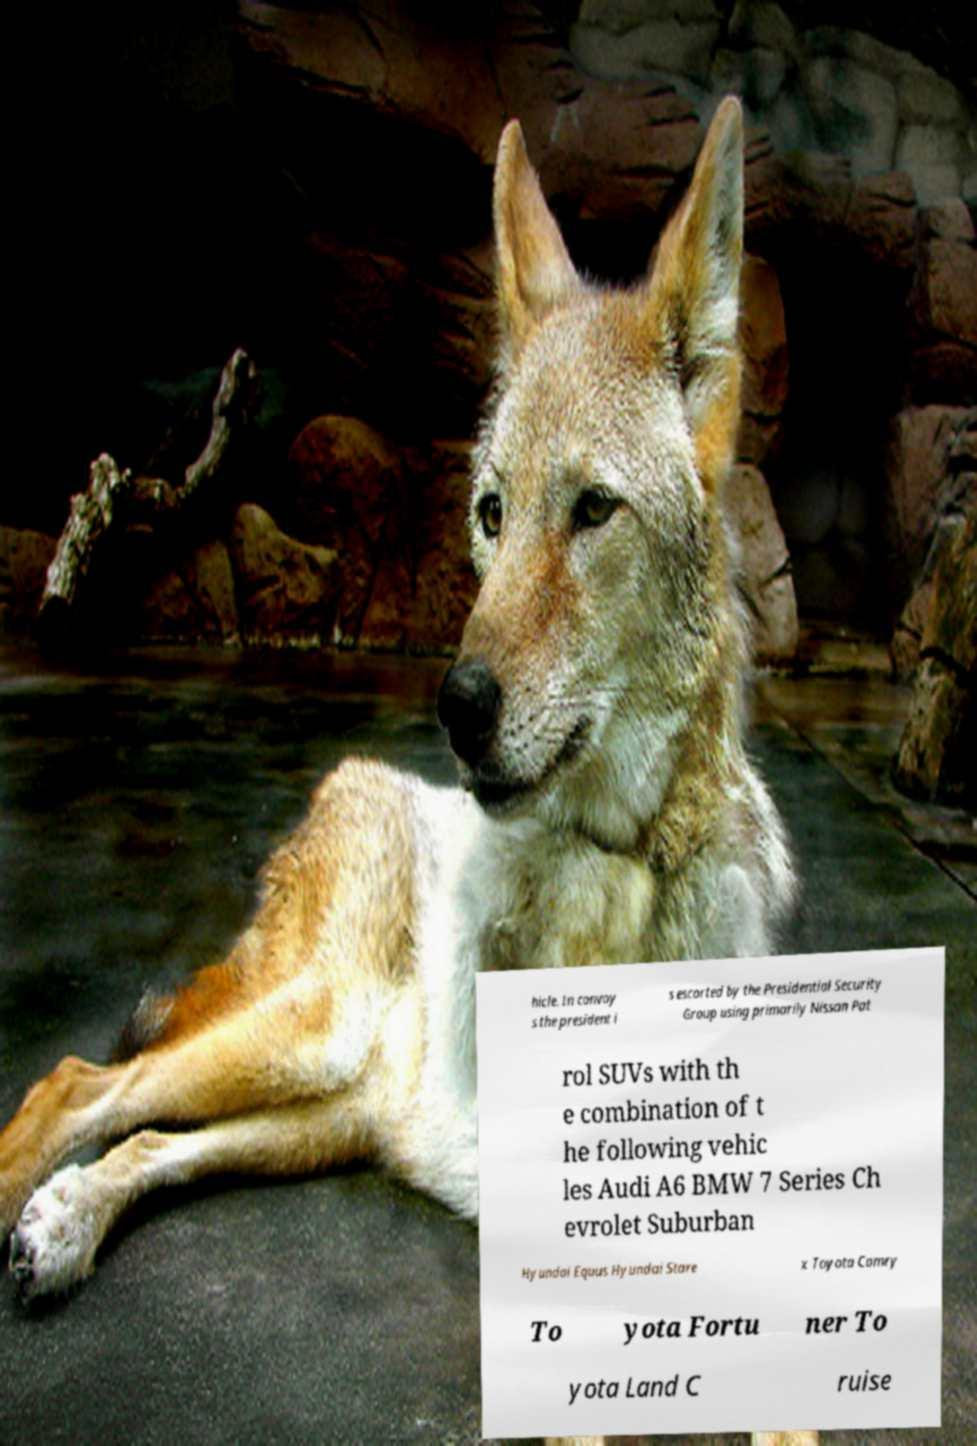Please read and relay the text visible in this image. What does it say? hicle. In convoy s the president i s escorted by the Presidential Security Group using primarily Nissan Pat rol SUVs with th e combination of t he following vehic les Audi A6 BMW 7 Series Ch evrolet Suburban Hyundai Equus Hyundai Stare x Toyota Camry To yota Fortu ner To yota Land C ruise 